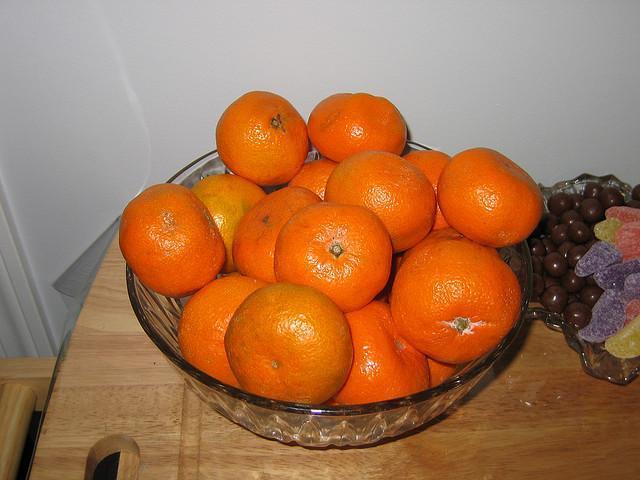How many varieties of fruit are on the counter?
Give a very brief answer. 2. How many different types of fruit are in the bowl?
Give a very brief answer. 1. How many oranges can you see?
Give a very brief answer. 10. How many people are sitting in a row on the sand?
Give a very brief answer. 0. 